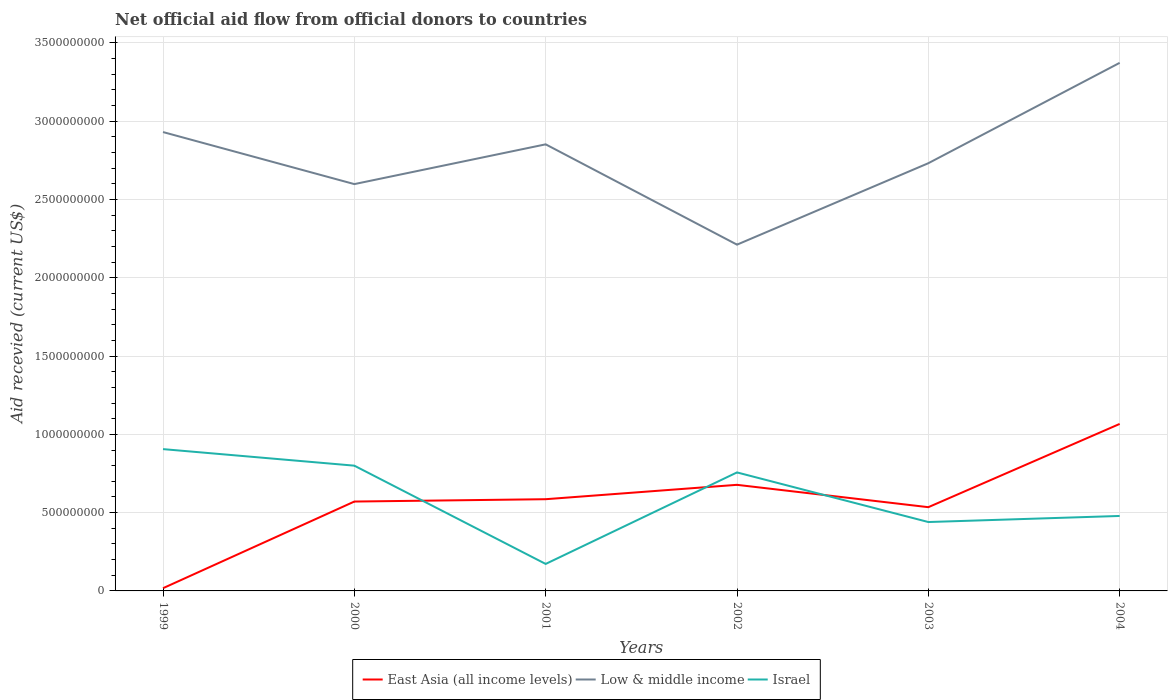How many different coloured lines are there?
Your answer should be very brief. 3. Does the line corresponding to Low & middle income intersect with the line corresponding to East Asia (all income levels)?
Offer a terse response. No. Is the number of lines equal to the number of legend labels?
Your answer should be very brief. Yes. Across all years, what is the maximum total aid received in East Asia (all income levels)?
Offer a very short reply. 1.74e+07. In which year was the total aid received in Israel maximum?
Your answer should be compact. 2001. What is the total total aid received in East Asia (all income levels) in the graph?
Offer a very short reply. -1.50e+07. What is the difference between the highest and the second highest total aid received in Low & middle income?
Provide a succinct answer. 1.16e+09. How many years are there in the graph?
Your answer should be compact. 6. Are the values on the major ticks of Y-axis written in scientific E-notation?
Give a very brief answer. No. Does the graph contain any zero values?
Your answer should be compact. No. Does the graph contain grids?
Your response must be concise. Yes. Where does the legend appear in the graph?
Your answer should be compact. Bottom center. How many legend labels are there?
Offer a very short reply. 3. How are the legend labels stacked?
Provide a short and direct response. Horizontal. What is the title of the graph?
Give a very brief answer. Net official aid flow from official donors to countries. Does "Solomon Islands" appear as one of the legend labels in the graph?
Ensure brevity in your answer.  No. What is the label or title of the X-axis?
Give a very brief answer. Years. What is the label or title of the Y-axis?
Provide a short and direct response. Aid recevied (current US$). What is the Aid recevied (current US$) of East Asia (all income levels) in 1999?
Offer a very short reply. 1.74e+07. What is the Aid recevied (current US$) of Low & middle income in 1999?
Provide a succinct answer. 2.93e+09. What is the Aid recevied (current US$) in Israel in 1999?
Your response must be concise. 9.06e+08. What is the Aid recevied (current US$) of East Asia (all income levels) in 2000?
Offer a terse response. 5.71e+08. What is the Aid recevied (current US$) in Low & middle income in 2000?
Offer a very short reply. 2.60e+09. What is the Aid recevied (current US$) of Israel in 2000?
Provide a short and direct response. 8.00e+08. What is the Aid recevied (current US$) in East Asia (all income levels) in 2001?
Keep it short and to the point. 5.86e+08. What is the Aid recevied (current US$) of Low & middle income in 2001?
Your answer should be very brief. 2.85e+09. What is the Aid recevied (current US$) in Israel in 2001?
Provide a succinct answer. 1.72e+08. What is the Aid recevied (current US$) of East Asia (all income levels) in 2002?
Your response must be concise. 6.78e+08. What is the Aid recevied (current US$) of Low & middle income in 2002?
Your answer should be very brief. 2.21e+09. What is the Aid recevied (current US$) in Israel in 2002?
Ensure brevity in your answer.  7.57e+08. What is the Aid recevied (current US$) in East Asia (all income levels) in 2003?
Offer a terse response. 5.35e+08. What is the Aid recevied (current US$) in Low & middle income in 2003?
Make the answer very short. 2.73e+09. What is the Aid recevied (current US$) in Israel in 2003?
Provide a succinct answer. 4.40e+08. What is the Aid recevied (current US$) of East Asia (all income levels) in 2004?
Offer a terse response. 1.07e+09. What is the Aid recevied (current US$) of Low & middle income in 2004?
Offer a very short reply. 3.37e+09. What is the Aid recevied (current US$) in Israel in 2004?
Ensure brevity in your answer.  4.79e+08. Across all years, what is the maximum Aid recevied (current US$) of East Asia (all income levels)?
Provide a succinct answer. 1.07e+09. Across all years, what is the maximum Aid recevied (current US$) of Low & middle income?
Make the answer very short. 3.37e+09. Across all years, what is the maximum Aid recevied (current US$) of Israel?
Your answer should be compact. 9.06e+08. Across all years, what is the minimum Aid recevied (current US$) of East Asia (all income levels)?
Offer a very short reply. 1.74e+07. Across all years, what is the minimum Aid recevied (current US$) of Low & middle income?
Provide a short and direct response. 2.21e+09. Across all years, what is the minimum Aid recevied (current US$) in Israel?
Your answer should be compact. 1.72e+08. What is the total Aid recevied (current US$) in East Asia (all income levels) in the graph?
Offer a terse response. 3.45e+09. What is the total Aid recevied (current US$) of Low & middle income in the graph?
Your answer should be compact. 1.67e+1. What is the total Aid recevied (current US$) of Israel in the graph?
Ensure brevity in your answer.  3.55e+09. What is the difference between the Aid recevied (current US$) of East Asia (all income levels) in 1999 and that in 2000?
Offer a terse response. -5.53e+08. What is the difference between the Aid recevied (current US$) in Low & middle income in 1999 and that in 2000?
Provide a succinct answer. 3.32e+08. What is the difference between the Aid recevied (current US$) of Israel in 1999 and that in 2000?
Provide a succinct answer. 1.06e+08. What is the difference between the Aid recevied (current US$) in East Asia (all income levels) in 1999 and that in 2001?
Give a very brief answer. -5.68e+08. What is the difference between the Aid recevied (current US$) of Low & middle income in 1999 and that in 2001?
Give a very brief answer. 7.84e+07. What is the difference between the Aid recevied (current US$) in Israel in 1999 and that in 2001?
Your answer should be compact. 7.33e+08. What is the difference between the Aid recevied (current US$) of East Asia (all income levels) in 1999 and that in 2002?
Offer a very short reply. -6.60e+08. What is the difference between the Aid recevied (current US$) in Low & middle income in 1999 and that in 2002?
Provide a succinct answer. 7.19e+08. What is the difference between the Aid recevied (current US$) in Israel in 1999 and that in 2002?
Keep it short and to the point. 1.49e+08. What is the difference between the Aid recevied (current US$) in East Asia (all income levels) in 1999 and that in 2003?
Offer a terse response. -5.18e+08. What is the difference between the Aid recevied (current US$) of Low & middle income in 1999 and that in 2003?
Your answer should be very brief. 1.99e+08. What is the difference between the Aid recevied (current US$) of Israel in 1999 and that in 2003?
Provide a succinct answer. 4.66e+08. What is the difference between the Aid recevied (current US$) of East Asia (all income levels) in 1999 and that in 2004?
Keep it short and to the point. -1.05e+09. What is the difference between the Aid recevied (current US$) of Low & middle income in 1999 and that in 2004?
Your answer should be compact. -4.42e+08. What is the difference between the Aid recevied (current US$) of Israel in 1999 and that in 2004?
Your answer should be compact. 4.27e+08. What is the difference between the Aid recevied (current US$) of East Asia (all income levels) in 2000 and that in 2001?
Provide a short and direct response. -1.50e+07. What is the difference between the Aid recevied (current US$) of Low & middle income in 2000 and that in 2001?
Give a very brief answer. -2.54e+08. What is the difference between the Aid recevied (current US$) in Israel in 2000 and that in 2001?
Ensure brevity in your answer.  6.28e+08. What is the difference between the Aid recevied (current US$) in East Asia (all income levels) in 2000 and that in 2002?
Ensure brevity in your answer.  -1.07e+08. What is the difference between the Aid recevied (current US$) in Low & middle income in 2000 and that in 2002?
Give a very brief answer. 3.87e+08. What is the difference between the Aid recevied (current US$) in Israel in 2000 and that in 2002?
Make the answer very short. 4.31e+07. What is the difference between the Aid recevied (current US$) of East Asia (all income levels) in 2000 and that in 2003?
Ensure brevity in your answer.  3.59e+07. What is the difference between the Aid recevied (current US$) in Low & middle income in 2000 and that in 2003?
Provide a short and direct response. -1.33e+08. What is the difference between the Aid recevied (current US$) of Israel in 2000 and that in 2003?
Offer a terse response. 3.60e+08. What is the difference between the Aid recevied (current US$) in East Asia (all income levels) in 2000 and that in 2004?
Offer a very short reply. -4.96e+08. What is the difference between the Aid recevied (current US$) of Low & middle income in 2000 and that in 2004?
Offer a very short reply. -7.74e+08. What is the difference between the Aid recevied (current US$) in Israel in 2000 and that in 2004?
Your answer should be very brief. 3.21e+08. What is the difference between the Aid recevied (current US$) of East Asia (all income levels) in 2001 and that in 2002?
Offer a very short reply. -9.18e+07. What is the difference between the Aid recevied (current US$) of Low & middle income in 2001 and that in 2002?
Provide a succinct answer. 6.41e+08. What is the difference between the Aid recevied (current US$) in Israel in 2001 and that in 2002?
Your answer should be compact. -5.85e+08. What is the difference between the Aid recevied (current US$) of East Asia (all income levels) in 2001 and that in 2003?
Offer a terse response. 5.10e+07. What is the difference between the Aid recevied (current US$) in Low & middle income in 2001 and that in 2003?
Your response must be concise. 1.21e+08. What is the difference between the Aid recevied (current US$) in Israel in 2001 and that in 2003?
Provide a succinct answer. -2.68e+08. What is the difference between the Aid recevied (current US$) of East Asia (all income levels) in 2001 and that in 2004?
Your response must be concise. -4.81e+08. What is the difference between the Aid recevied (current US$) in Low & middle income in 2001 and that in 2004?
Make the answer very short. -5.20e+08. What is the difference between the Aid recevied (current US$) in Israel in 2001 and that in 2004?
Your answer should be compact. -3.06e+08. What is the difference between the Aid recevied (current US$) of East Asia (all income levels) in 2002 and that in 2003?
Ensure brevity in your answer.  1.43e+08. What is the difference between the Aid recevied (current US$) of Low & middle income in 2002 and that in 2003?
Your answer should be compact. -5.20e+08. What is the difference between the Aid recevied (current US$) of Israel in 2002 and that in 2003?
Ensure brevity in your answer.  3.17e+08. What is the difference between the Aid recevied (current US$) of East Asia (all income levels) in 2002 and that in 2004?
Offer a very short reply. -3.89e+08. What is the difference between the Aid recevied (current US$) in Low & middle income in 2002 and that in 2004?
Keep it short and to the point. -1.16e+09. What is the difference between the Aid recevied (current US$) in Israel in 2002 and that in 2004?
Give a very brief answer. 2.78e+08. What is the difference between the Aid recevied (current US$) of East Asia (all income levels) in 2003 and that in 2004?
Your response must be concise. -5.32e+08. What is the difference between the Aid recevied (current US$) in Low & middle income in 2003 and that in 2004?
Give a very brief answer. -6.41e+08. What is the difference between the Aid recevied (current US$) of Israel in 2003 and that in 2004?
Ensure brevity in your answer.  -3.89e+07. What is the difference between the Aid recevied (current US$) of East Asia (all income levels) in 1999 and the Aid recevied (current US$) of Low & middle income in 2000?
Make the answer very short. -2.58e+09. What is the difference between the Aid recevied (current US$) of East Asia (all income levels) in 1999 and the Aid recevied (current US$) of Israel in 2000?
Your answer should be compact. -7.83e+08. What is the difference between the Aid recevied (current US$) in Low & middle income in 1999 and the Aid recevied (current US$) in Israel in 2000?
Your response must be concise. 2.13e+09. What is the difference between the Aid recevied (current US$) in East Asia (all income levels) in 1999 and the Aid recevied (current US$) in Low & middle income in 2001?
Your response must be concise. -2.83e+09. What is the difference between the Aid recevied (current US$) in East Asia (all income levels) in 1999 and the Aid recevied (current US$) in Israel in 2001?
Your answer should be compact. -1.55e+08. What is the difference between the Aid recevied (current US$) of Low & middle income in 1999 and the Aid recevied (current US$) of Israel in 2001?
Your answer should be very brief. 2.76e+09. What is the difference between the Aid recevied (current US$) in East Asia (all income levels) in 1999 and the Aid recevied (current US$) in Low & middle income in 2002?
Give a very brief answer. -2.19e+09. What is the difference between the Aid recevied (current US$) in East Asia (all income levels) in 1999 and the Aid recevied (current US$) in Israel in 2002?
Your answer should be compact. -7.40e+08. What is the difference between the Aid recevied (current US$) of Low & middle income in 1999 and the Aid recevied (current US$) of Israel in 2002?
Offer a very short reply. 2.17e+09. What is the difference between the Aid recevied (current US$) in East Asia (all income levels) in 1999 and the Aid recevied (current US$) in Low & middle income in 2003?
Ensure brevity in your answer.  -2.71e+09. What is the difference between the Aid recevied (current US$) of East Asia (all income levels) in 1999 and the Aid recevied (current US$) of Israel in 2003?
Make the answer very short. -4.23e+08. What is the difference between the Aid recevied (current US$) of Low & middle income in 1999 and the Aid recevied (current US$) of Israel in 2003?
Offer a very short reply. 2.49e+09. What is the difference between the Aid recevied (current US$) of East Asia (all income levels) in 1999 and the Aid recevied (current US$) of Low & middle income in 2004?
Your response must be concise. -3.36e+09. What is the difference between the Aid recevied (current US$) of East Asia (all income levels) in 1999 and the Aid recevied (current US$) of Israel in 2004?
Provide a short and direct response. -4.62e+08. What is the difference between the Aid recevied (current US$) of Low & middle income in 1999 and the Aid recevied (current US$) of Israel in 2004?
Make the answer very short. 2.45e+09. What is the difference between the Aid recevied (current US$) in East Asia (all income levels) in 2000 and the Aid recevied (current US$) in Low & middle income in 2001?
Ensure brevity in your answer.  -2.28e+09. What is the difference between the Aid recevied (current US$) of East Asia (all income levels) in 2000 and the Aid recevied (current US$) of Israel in 2001?
Keep it short and to the point. 3.98e+08. What is the difference between the Aid recevied (current US$) of Low & middle income in 2000 and the Aid recevied (current US$) of Israel in 2001?
Provide a short and direct response. 2.43e+09. What is the difference between the Aid recevied (current US$) in East Asia (all income levels) in 2000 and the Aid recevied (current US$) in Low & middle income in 2002?
Your answer should be very brief. -1.64e+09. What is the difference between the Aid recevied (current US$) in East Asia (all income levels) in 2000 and the Aid recevied (current US$) in Israel in 2002?
Ensure brevity in your answer.  -1.86e+08. What is the difference between the Aid recevied (current US$) of Low & middle income in 2000 and the Aid recevied (current US$) of Israel in 2002?
Give a very brief answer. 1.84e+09. What is the difference between the Aid recevied (current US$) of East Asia (all income levels) in 2000 and the Aid recevied (current US$) of Low & middle income in 2003?
Keep it short and to the point. -2.16e+09. What is the difference between the Aid recevied (current US$) in East Asia (all income levels) in 2000 and the Aid recevied (current US$) in Israel in 2003?
Ensure brevity in your answer.  1.31e+08. What is the difference between the Aid recevied (current US$) in Low & middle income in 2000 and the Aid recevied (current US$) in Israel in 2003?
Provide a short and direct response. 2.16e+09. What is the difference between the Aid recevied (current US$) in East Asia (all income levels) in 2000 and the Aid recevied (current US$) in Low & middle income in 2004?
Keep it short and to the point. -2.80e+09. What is the difference between the Aid recevied (current US$) of East Asia (all income levels) in 2000 and the Aid recevied (current US$) of Israel in 2004?
Keep it short and to the point. 9.19e+07. What is the difference between the Aid recevied (current US$) of Low & middle income in 2000 and the Aid recevied (current US$) of Israel in 2004?
Keep it short and to the point. 2.12e+09. What is the difference between the Aid recevied (current US$) of East Asia (all income levels) in 2001 and the Aid recevied (current US$) of Low & middle income in 2002?
Make the answer very short. -1.63e+09. What is the difference between the Aid recevied (current US$) in East Asia (all income levels) in 2001 and the Aid recevied (current US$) in Israel in 2002?
Your answer should be very brief. -1.71e+08. What is the difference between the Aid recevied (current US$) in Low & middle income in 2001 and the Aid recevied (current US$) in Israel in 2002?
Give a very brief answer. 2.10e+09. What is the difference between the Aid recevied (current US$) of East Asia (all income levels) in 2001 and the Aid recevied (current US$) of Low & middle income in 2003?
Provide a succinct answer. -2.15e+09. What is the difference between the Aid recevied (current US$) in East Asia (all income levels) in 2001 and the Aid recevied (current US$) in Israel in 2003?
Keep it short and to the point. 1.46e+08. What is the difference between the Aid recevied (current US$) of Low & middle income in 2001 and the Aid recevied (current US$) of Israel in 2003?
Provide a succinct answer. 2.41e+09. What is the difference between the Aid recevied (current US$) of East Asia (all income levels) in 2001 and the Aid recevied (current US$) of Low & middle income in 2004?
Your answer should be compact. -2.79e+09. What is the difference between the Aid recevied (current US$) of East Asia (all income levels) in 2001 and the Aid recevied (current US$) of Israel in 2004?
Give a very brief answer. 1.07e+08. What is the difference between the Aid recevied (current US$) in Low & middle income in 2001 and the Aid recevied (current US$) in Israel in 2004?
Ensure brevity in your answer.  2.37e+09. What is the difference between the Aid recevied (current US$) in East Asia (all income levels) in 2002 and the Aid recevied (current US$) in Low & middle income in 2003?
Your answer should be compact. -2.05e+09. What is the difference between the Aid recevied (current US$) of East Asia (all income levels) in 2002 and the Aid recevied (current US$) of Israel in 2003?
Your response must be concise. 2.38e+08. What is the difference between the Aid recevied (current US$) in Low & middle income in 2002 and the Aid recevied (current US$) in Israel in 2003?
Give a very brief answer. 1.77e+09. What is the difference between the Aid recevied (current US$) of East Asia (all income levels) in 2002 and the Aid recevied (current US$) of Low & middle income in 2004?
Your answer should be very brief. -2.70e+09. What is the difference between the Aid recevied (current US$) of East Asia (all income levels) in 2002 and the Aid recevied (current US$) of Israel in 2004?
Provide a short and direct response. 1.99e+08. What is the difference between the Aid recevied (current US$) of Low & middle income in 2002 and the Aid recevied (current US$) of Israel in 2004?
Ensure brevity in your answer.  1.73e+09. What is the difference between the Aid recevied (current US$) in East Asia (all income levels) in 2003 and the Aid recevied (current US$) in Low & middle income in 2004?
Offer a terse response. -2.84e+09. What is the difference between the Aid recevied (current US$) of East Asia (all income levels) in 2003 and the Aid recevied (current US$) of Israel in 2004?
Your response must be concise. 5.60e+07. What is the difference between the Aid recevied (current US$) of Low & middle income in 2003 and the Aid recevied (current US$) of Israel in 2004?
Make the answer very short. 2.25e+09. What is the average Aid recevied (current US$) of East Asia (all income levels) per year?
Your answer should be compact. 5.75e+08. What is the average Aid recevied (current US$) in Low & middle income per year?
Give a very brief answer. 2.78e+09. What is the average Aid recevied (current US$) of Israel per year?
Keep it short and to the point. 5.92e+08. In the year 1999, what is the difference between the Aid recevied (current US$) of East Asia (all income levels) and Aid recevied (current US$) of Low & middle income?
Your answer should be compact. -2.91e+09. In the year 1999, what is the difference between the Aid recevied (current US$) in East Asia (all income levels) and Aid recevied (current US$) in Israel?
Give a very brief answer. -8.88e+08. In the year 1999, what is the difference between the Aid recevied (current US$) in Low & middle income and Aid recevied (current US$) in Israel?
Your answer should be very brief. 2.03e+09. In the year 2000, what is the difference between the Aid recevied (current US$) in East Asia (all income levels) and Aid recevied (current US$) in Low & middle income?
Give a very brief answer. -2.03e+09. In the year 2000, what is the difference between the Aid recevied (current US$) of East Asia (all income levels) and Aid recevied (current US$) of Israel?
Offer a terse response. -2.29e+08. In the year 2000, what is the difference between the Aid recevied (current US$) in Low & middle income and Aid recevied (current US$) in Israel?
Ensure brevity in your answer.  1.80e+09. In the year 2001, what is the difference between the Aid recevied (current US$) of East Asia (all income levels) and Aid recevied (current US$) of Low & middle income?
Your answer should be compact. -2.27e+09. In the year 2001, what is the difference between the Aid recevied (current US$) in East Asia (all income levels) and Aid recevied (current US$) in Israel?
Offer a terse response. 4.13e+08. In the year 2001, what is the difference between the Aid recevied (current US$) of Low & middle income and Aid recevied (current US$) of Israel?
Provide a succinct answer. 2.68e+09. In the year 2002, what is the difference between the Aid recevied (current US$) of East Asia (all income levels) and Aid recevied (current US$) of Low & middle income?
Your answer should be very brief. -1.53e+09. In the year 2002, what is the difference between the Aid recevied (current US$) in East Asia (all income levels) and Aid recevied (current US$) in Israel?
Provide a succinct answer. -7.93e+07. In the year 2002, what is the difference between the Aid recevied (current US$) of Low & middle income and Aid recevied (current US$) of Israel?
Offer a very short reply. 1.45e+09. In the year 2003, what is the difference between the Aid recevied (current US$) of East Asia (all income levels) and Aid recevied (current US$) of Low & middle income?
Offer a terse response. -2.20e+09. In the year 2003, what is the difference between the Aid recevied (current US$) of East Asia (all income levels) and Aid recevied (current US$) of Israel?
Your response must be concise. 9.49e+07. In the year 2003, what is the difference between the Aid recevied (current US$) of Low & middle income and Aid recevied (current US$) of Israel?
Offer a terse response. 2.29e+09. In the year 2004, what is the difference between the Aid recevied (current US$) of East Asia (all income levels) and Aid recevied (current US$) of Low & middle income?
Keep it short and to the point. -2.31e+09. In the year 2004, what is the difference between the Aid recevied (current US$) of East Asia (all income levels) and Aid recevied (current US$) of Israel?
Provide a succinct answer. 5.88e+08. In the year 2004, what is the difference between the Aid recevied (current US$) of Low & middle income and Aid recevied (current US$) of Israel?
Your answer should be compact. 2.89e+09. What is the ratio of the Aid recevied (current US$) of East Asia (all income levels) in 1999 to that in 2000?
Your response must be concise. 0.03. What is the ratio of the Aid recevied (current US$) of Low & middle income in 1999 to that in 2000?
Give a very brief answer. 1.13. What is the ratio of the Aid recevied (current US$) in Israel in 1999 to that in 2000?
Keep it short and to the point. 1.13. What is the ratio of the Aid recevied (current US$) of East Asia (all income levels) in 1999 to that in 2001?
Provide a succinct answer. 0.03. What is the ratio of the Aid recevied (current US$) of Low & middle income in 1999 to that in 2001?
Give a very brief answer. 1.03. What is the ratio of the Aid recevied (current US$) in Israel in 1999 to that in 2001?
Offer a terse response. 5.26. What is the ratio of the Aid recevied (current US$) of East Asia (all income levels) in 1999 to that in 2002?
Give a very brief answer. 0.03. What is the ratio of the Aid recevied (current US$) in Low & middle income in 1999 to that in 2002?
Offer a very short reply. 1.33. What is the ratio of the Aid recevied (current US$) of Israel in 1999 to that in 2002?
Provide a succinct answer. 1.2. What is the ratio of the Aid recevied (current US$) in East Asia (all income levels) in 1999 to that in 2003?
Give a very brief answer. 0.03. What is the ratio of the Aid recevied (current US$) in Low & middle income in 1999 to that in 2003?
Your answer should be very brief. 1.07. What is the ratio of the Aid recevied (current US$) of Israel in 1999 to that in 2003?
Make the answer very short. 2.06. What is the ratio of the Aid recevied (current US$) of East Asia (all income levels) in 1999 to that in 2004?
Give a very brief answer. 0.02. What is the ratio of the Aid recevied (current US$) of Low & middle income in 1999 to that in 2004?
Offer a very short reply. 0.87. What is the ratio of the Aid recevied (current US$) in Israel in 1999 to that in 2004?
Ensure brevity in your answer.  1.89. What is the ratio of the Aid recevied (current US$) of East Asia (all income levels) in 2000 to that in 2001?
Keep it short and to the point. 0.97. What is the ratio of the Aid recevied (current US$) of Low & middle income in 2000 to that in 2001?
Give a very brief answer. 0.91. What is the ratio of the Aid recevied (current US$) in Israel in 2000 to that in 2001?
Make the answer very short. 4.64. What is the ratio of the Aid recevied (current US$) of East Asia (all income levels) in 2000 to that in 2002?
Give a very brief answer. 0.84. What is the ratio of the Aid recevied (current US$) in Low & middle income in 2000 to that in 2002?
Give a very brief answer. 1.17. What is the ratio of the Aid recevied (current US$) of Israel in 2000 to that in 2002?
Make the answer very short. 1.06. What is the ratio of the Aid recevied (current US$) in East Asia (all income levels) in 2000 to that in 2003?
Provide a succinct answer. 1.07. What is the ratio of the Aid recevied (current US$) of Low & middle income in 2000 to that in 2003?
Your answer should be compact. 0.95. What is the ratio of the Aid recevied (current US$) in Israel in 2000 to that in 2003?
Your response must be concise. 1.82. What is the ratio of the Aid recevied (current US$) in East Asia (all income levels) in 2000 to that in 2004?
Provide a succinct answer. 0.54. What is the ratio of the Aid recevied (current US$) in Low & middle income in 2000 to that in 2004?
Provide a short and direct response. 0.77. What is the ratio of the Aid recevied (current US$) in Israel in 2000 to that in 2004?
Make the answer very short. 1.67. What is the ratio of the Aid recevied (current US$) of East Asia (all income levels) in 2001 to that in 2002?
Offer a terse response. 0.86. What is the ratio of the Aid recevied (current US$) of Low & middle income in 2001 to that in 2002?
Provide a succinct answer. 1.29. What is the ratio of the Aid recevied (current US$) of Israel in 2001 to that in 2002?
Offer a terse response. 0.23. What is the ratio of the Aid recevied (current US$) in East Asia (all income levels) in 2001 to that in 2003?
Provide a succinct answer. 1.1. What is the ratio of the Aid recevied (current US$) in Low & middle income in 2001 to that in 2003?
Your answer should be very brief. 1.04. What is the ratio of the Aid recevied (current US$) of Israel in 2001 to that in 2003?
Offer a very short reply. 0.39. What is the ratio of the Aid recevied (current US$) in East Asia (all income levels) in 2001 to that in 2004?
Provide a succinct answer. 0.55. What is the ratio of the Aid recevied (current US$) in Low & middle income in 2001 to that in 2004?
Offer a very short reply. 0.85. What is the ratio of the Aid recevied (current US$) in Israel in 2001 to that in 2004?
Offer a terse response. 0.36. What is the ratio of the Aid recevied (current US$) in East Asia (all income levels) in 2002 to that in 2003?
Make the answer very short. 1.27. What is the ratio of the Aid recevied (current US$) in Low & middle income in 2002 to that in 2003?
Give a very brief answer. 0.81. What is the ratio of the Aid recevied (current US$) in Israel in 2002 to that in 2003?
Keep it short and to the point. 1.72. What is the ratio of the Aid recevied (current US$) in East Asia (all income levels) in 2002 to that in 2004?
Make the answer very short. 0.64. What is the ratio of the Aid recevied (current US$) of Low & middle income in 2002 to that in 2004?
Keep it short and to the point. 0.66. What is the ratio of the Aid recevied (current US$) in Israel in 2002 to that in 2004?
Your answer should be compact. 1.58. What is the ratio of the Aid recevied (current US$) in East Asia (all income levels) in 2003 to that in 2004?
Keep it short and to the point. 0.5. What is the ratio of the Aid recevied (current US$) of Low & middle income in 2003 to that in 2004?
Ensure brevity in your answer.  0.81. What is the ratio of the Aid recevied (current US$) of Israel in 2003 to that in 2004?
Your answer should be very brief. 0.92. What is the difference between the highest and the second highest Aid recevied (current US$) of East Asia (all income levels)?
Your response must be concise. 3.89e+08. What is the difference between the highest and the second highest Aid recevied (current US$) of Low & middle income?
Provide a succinct answer. 4.42e+08. What is the difference between the highest and the second highest Aid recevied (current US$) of Israel?
Offer a terse response. 1.06e+08. What is the difference between the highest and the lowest Aid recevied (current US$) of East Asia (all income levels)?
Your answer should be compact. 1.05e+09. What is the difference between the highest and the lowest Aid recevied (current US$) in Low & middle income?
Your answer should be very brief. 1.16e+09. What is the difference between the highest and the lowest Aid recevied (current US$) in Israel?
Ensure brevity in your answer.  7.33e+08. 